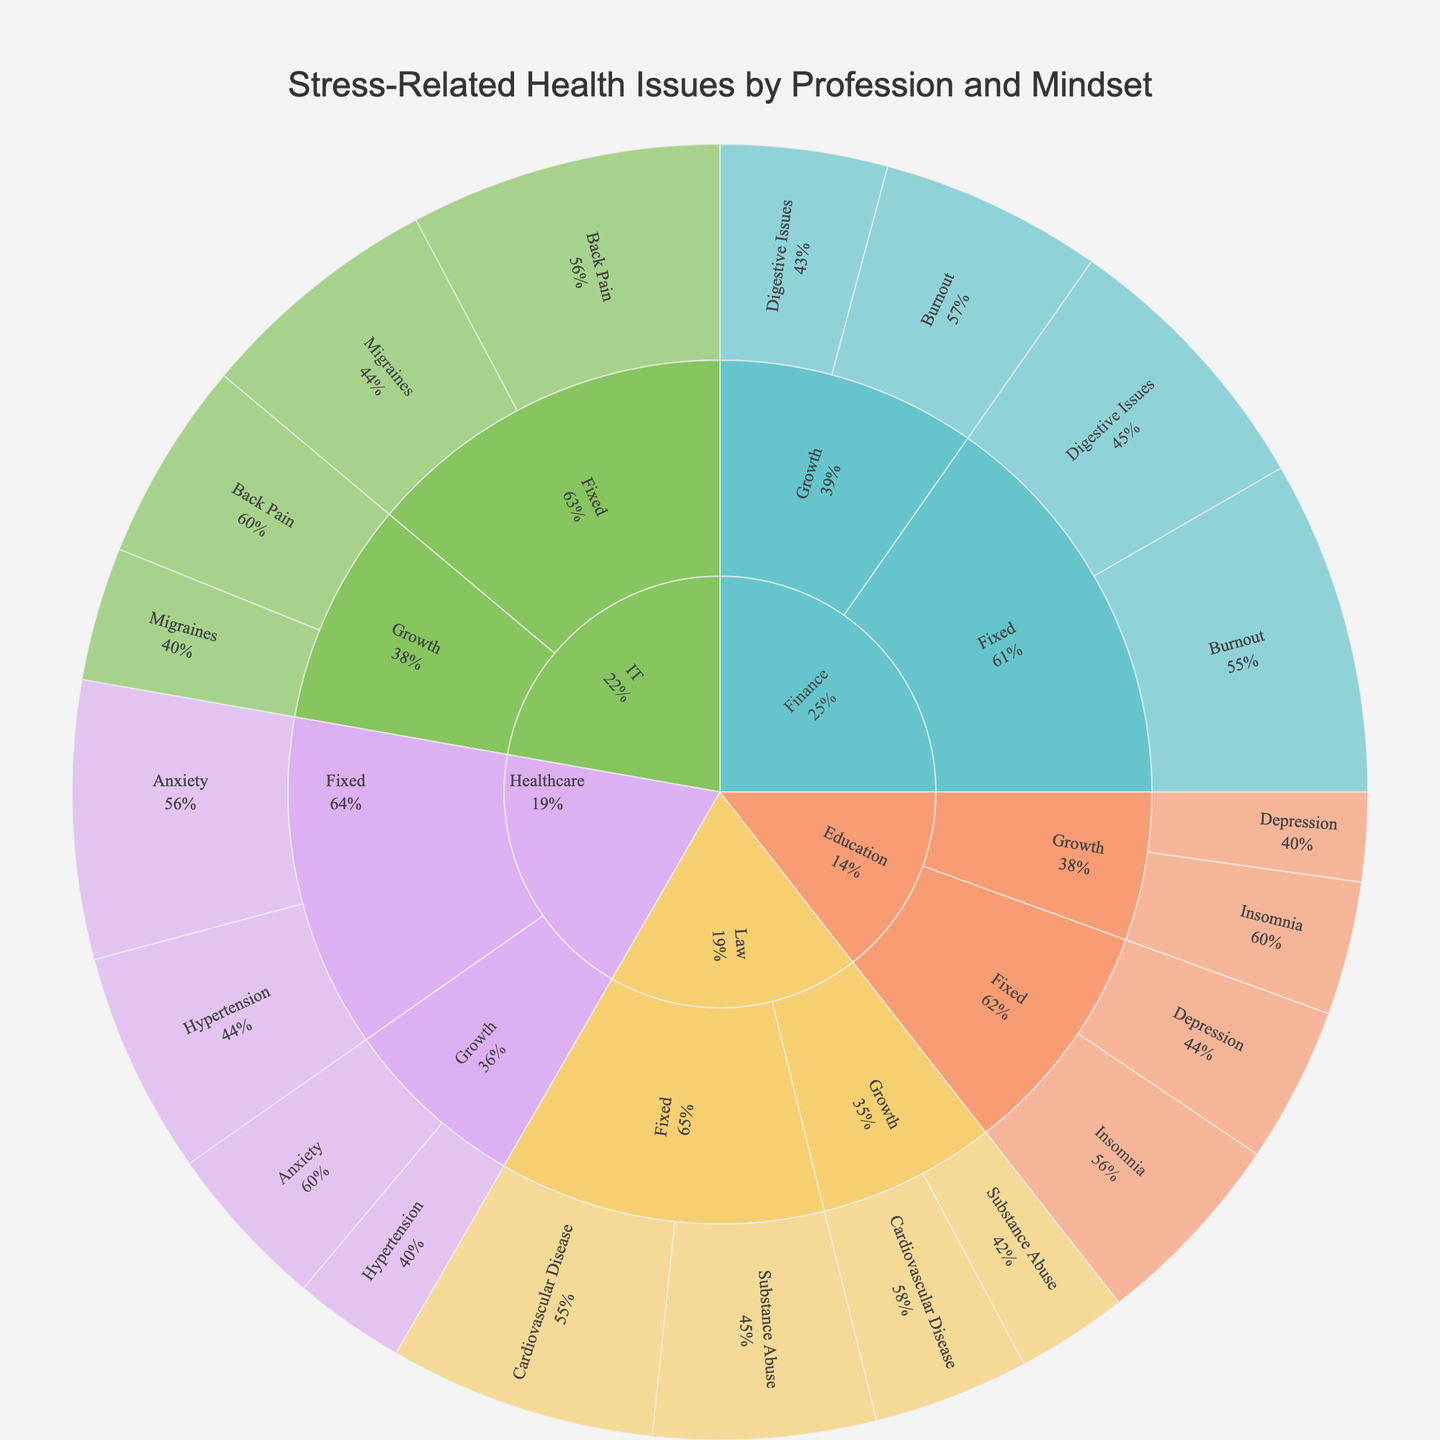What is the title of the sunburst plot? The title of the sunburst plot is typically found at the top of the figure and summarizes the overall content being displayed. In this case, it is explicitly set in the code provided.
Answer: Stress-Related Health Issues by Profession and Mindset Which profession, mindset, and health issue combination has the highest percentage of stress-related health issues? To find the combination with the highest percentage, we need to look at each segment of the sunburst plot and identify which one has the highest percentage value.
Answer: Finance, Fixed, Burnout Compare the percentages of Insomnia in the Education profession between Growth and Fixed mindsets. Which mindset has a higher percentage? Find the percentages of Insomnia for both Growth and Fixed mindsets under the Education profession in the sunburst plot and compare them. The Growth mindset has a percentage of 12%, while the Fixed mindset has 18%.
Answer: Fixed mindset What is the percentage difference in Anxiety-related health issues between Healthcare professionals with Growth and Fixed mindsets? Calculate the percentage difference by subtracting the percentage of Healthcare professionals with Growth mindset (15%) from those with Fixed mindset (25%).
Answer: 10% Which health issue is more prevalent among IT professionals with a Fixed mindset compared to those with a Growth mindset? Compare the percentages of each health issue (Back Pain and Migraines) between IT professionals with Fixed and Growth mindsets. Fixed mindset shows 28% for Back Pain and 22% for Migraines, while Growth mindset shows 18% and 12% respectively.
Answer: Back Pain Among Law professionals, which health issue is more common for those with a Growth mindset compared to a Fixed mindset? Look for health issues in the Law profession and compare their percentages between Growth and Fixed mindsets. For Growth mindset, Cardiovascular Disease is 14% and Substance Abuse is 10%. For Fixed mindset, Cardiovascular Disease is 24% and Substance Abuse is 20%.
Answer: Cardiovascular Disease What is the total percentage of stress-related health issues for Finance professionals? Sum the percentages of all stress-related health issues for both Growth and Fixed mindsets under the Finance profession. For Growth mindset, the total is 20% + 15% (Burnout and Digestive Issues). For Fixed mindset, it is 30% + 25%. Sum these totals together.
Answer: 90% How does the prevalence of Hypertension compare between Healthcare professionals with Growth and Fixed mindsets? Find the percentages of Hypertension under the Healthcare profession for both Growth and Fixed mindsets. Growth mindset has 10%, while Fixed mindset has 20%.
Answer: Fixed mindset is higher Which mindset type in the Education profession has a higher overall percentage of stress-related health issues? Add up the percentages of all stress-related health issues for Growth and Fixed mindsets within the Education profession. Growth mindset has 12% (Insomnia) + 8% (Depression) = 20%. Fixed mindset has 18% (Insomnia) + 14% (Depression) = 32%.
Answer: Fixed mindset What is the ratio of Burnout cases in the Finance profession between Fixed and Growth mindsets? Divide the percentage of Burnout cases under Fixed mindset (30%) by the percentage under Growth mindset (20%).
Answer: 1.5:1 